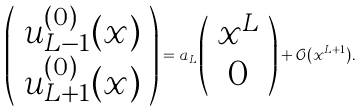<formula> <loc_0><loc_0><loc_500><loc_500>\left ( \begin{array} { c } u ^ { ( 0 ) } _ { L - 1 } ( x ) \\ u ^ { ( 0 ) } _ { L + 1 } ( x ) \\ \end{array} \right ) = a _ { L } \left ( \begin{array} { c } x ^ { L } \\ 0 \\ \end{array} \right ) + { \mathcal { O } } ( x ^ { L + 1 } ) .</formula> 